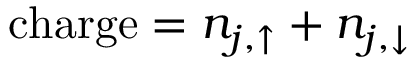<formula> <loc_0><loc_0><loc_500><loc_500>c h \arg e = n _ { j , \uparrow } + n _ { j , \downarrow }</formula> 